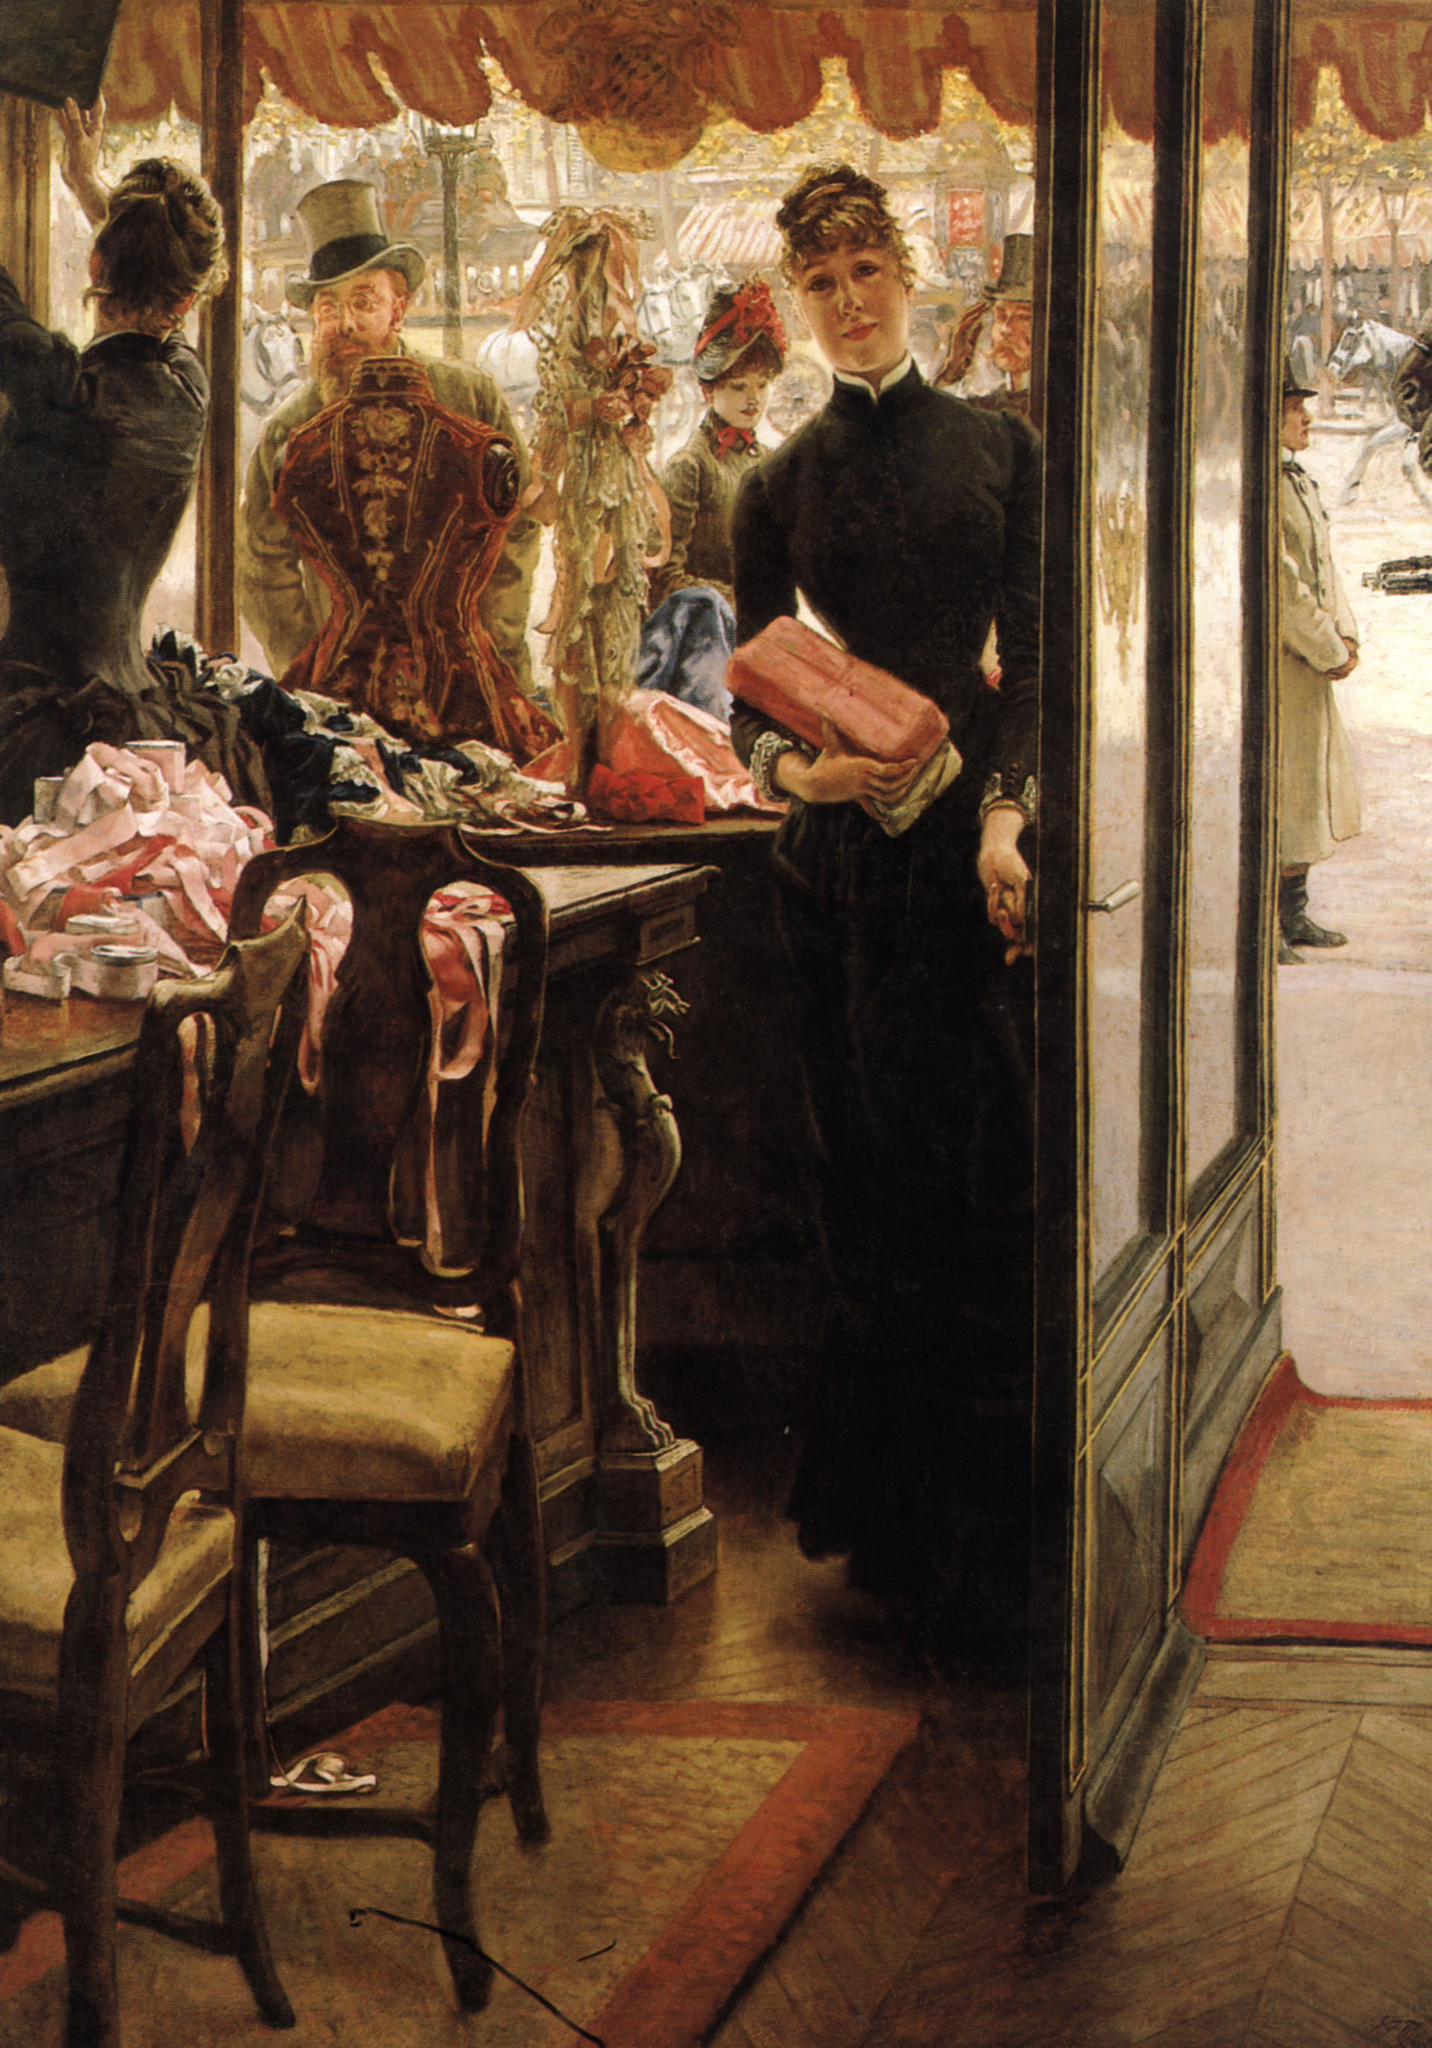If modern technology existed in the time this painting was set, how might this scene look different? If modern technology existed in Victorian times, the scene would be transformed significantly. Eliza might be dressed in contemporary, fashion-forward attire, possibly using a tablet to manage inventory or display information about the shop's items. The shop could be illuminated with bright, energy-efficient LED lighting, enhancing the vibrancy of the colors and fabrics. Outside, the street would buzz with the presence of electric cars and scooters zipping by, and large digital billboards displaying advertisements for the latest trends seen from the window. Perhaps the boutique would have an online presence, with Eliza occasionally checking social media notifications or an e-commerce site for orders. The essence of the shop might still capture the artistry and care in its presentation, but the technological overlays would definitely introduce a new, exciting dynamic to this historically rich setting. 